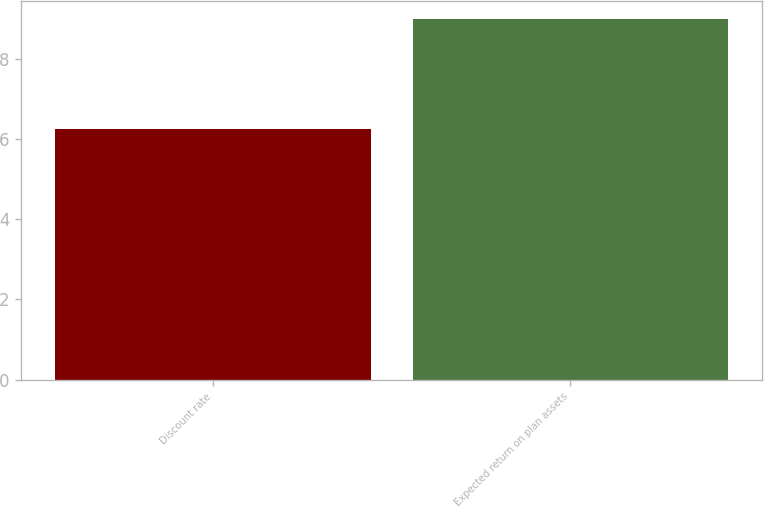<chart> <loc_0><loc_0><loc_500><loc_500><bar_chart><fcel>Discount rate<fcel>Expected return on plan assets<nl><fcel>6.25<fcel>9<nl></chart> 